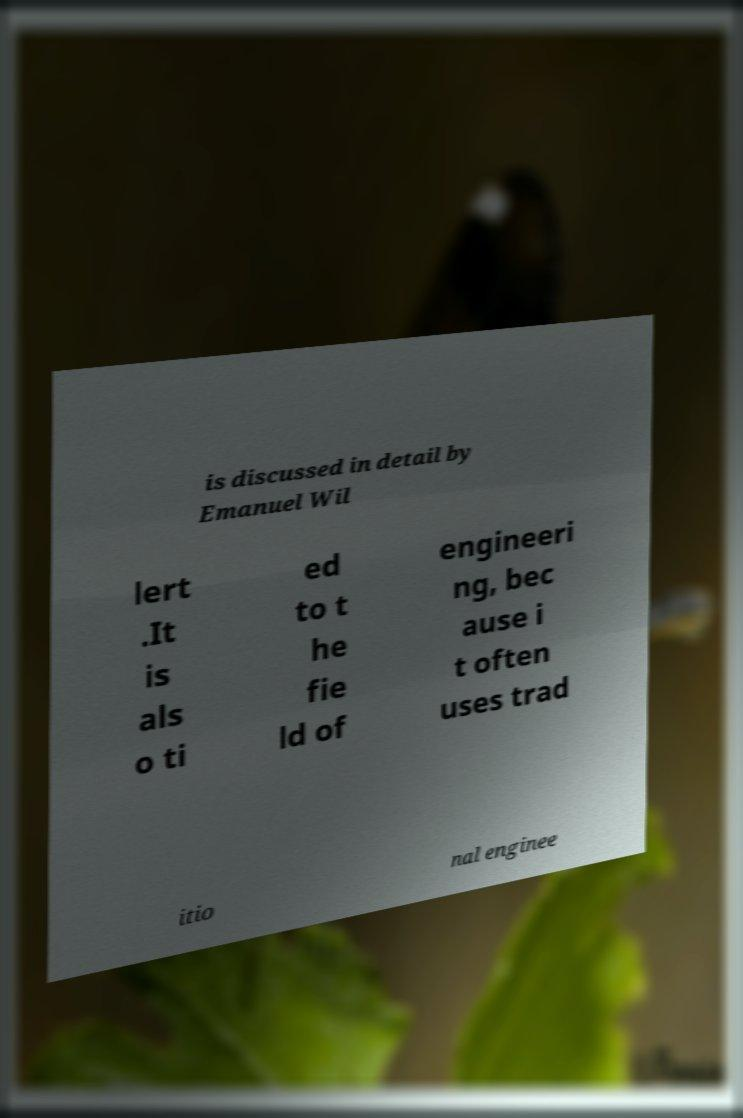Can you read and provide the text displayed in the image?This photo seems to have some interesting text. Can you extract and type it out for me? is discussed in detail by Emanuel Wil lert .It is als o ti ed to t he fie ld of engineeri ng, bec ause i t often uses trad itio nal enginee 